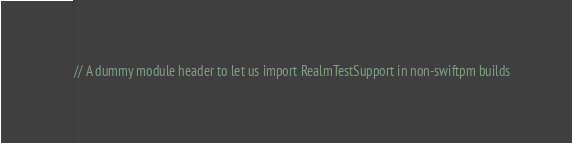<code> <loc_0><loc_0><loc_500><loc_500><_C_>// A dummy module header to let us import RealmTestSupport in non-swiftpm builds
</code> 